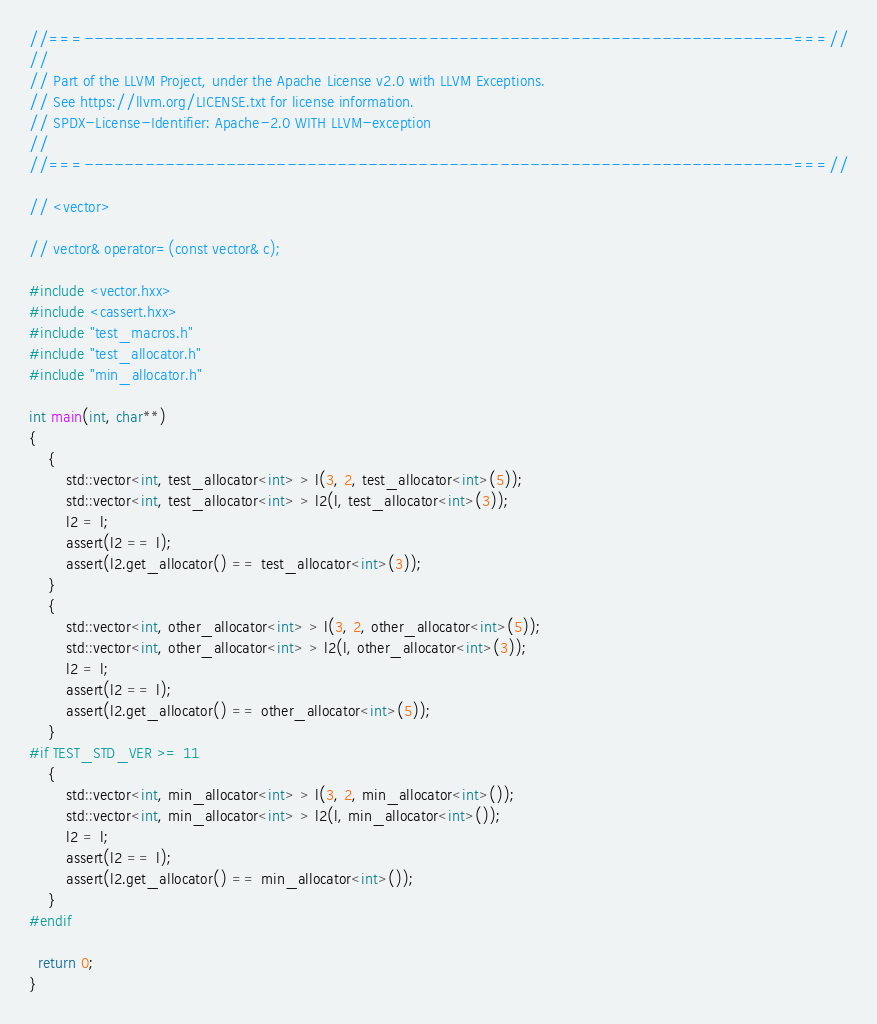Convert code to text. <code><loc_0><loc_0><loc_500><loc_500><_C++_>//===----------------------------------------------------------------------===//
//
// Part of the LLVM Project, under the Apache License v2.0 with LLVM Exceptions.
// See https://llvm.org/LICENSE.txt for license information.
// SPDX-License-Identifier: Apache-2.0 WITH LLVM-exception
//
//===----------------------------------------------------------------------===//

// <vector>

// vector& operator=(const vector& c);

#include <vector.hxx>
#include <cassert.hxx>
#include "test_macros.h"
#include "test_allocator.h"
#include "min_allocator.h"

int main(int, char**)
{
    {
        std::vector<int, test_allocator<int> > l(3, 2, test_allocator<int>(5));
        std::vector<int, test_allocator<int> > l2(l, test_allocator<int>(3));
        l2 = l;
        assert(l2 == l);
        assert(l2.get_allocator() == test_allocator<int>(3));
    }
    {
        std::vector<int, other_allocator<int> > l(3, 2, other_allocator<int>(5));
        std::vector<int, other_allocator<int> > l2(l, other_allocator<int>(3));
        l2 = l;
        assert(l2 == l);
        assert(l2.get_allocator() == other_allocator<int>(5));
    }
#if TEST_STD_VER >= 11
    {
        std::vector<int, min_allocator<int> > l(3, 2, min_allocator<int>());
        std::vector<int, min_allocator<int> > l2(l, min_allocator<int>());
        l2 = l;
        assert(l2 == l);
        assert(l2.get_allocator() == min_allocator<int>());
    }
#endif

  return 0;
}
</code> 